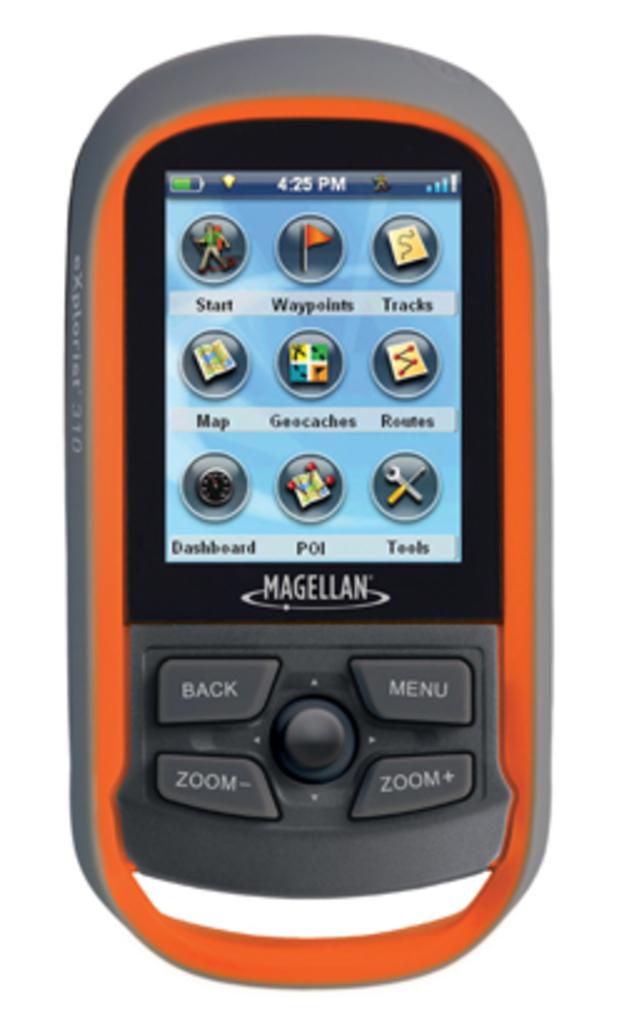<image>
Share a concise interpretation of the image provided. a phone with the word magellan on it 